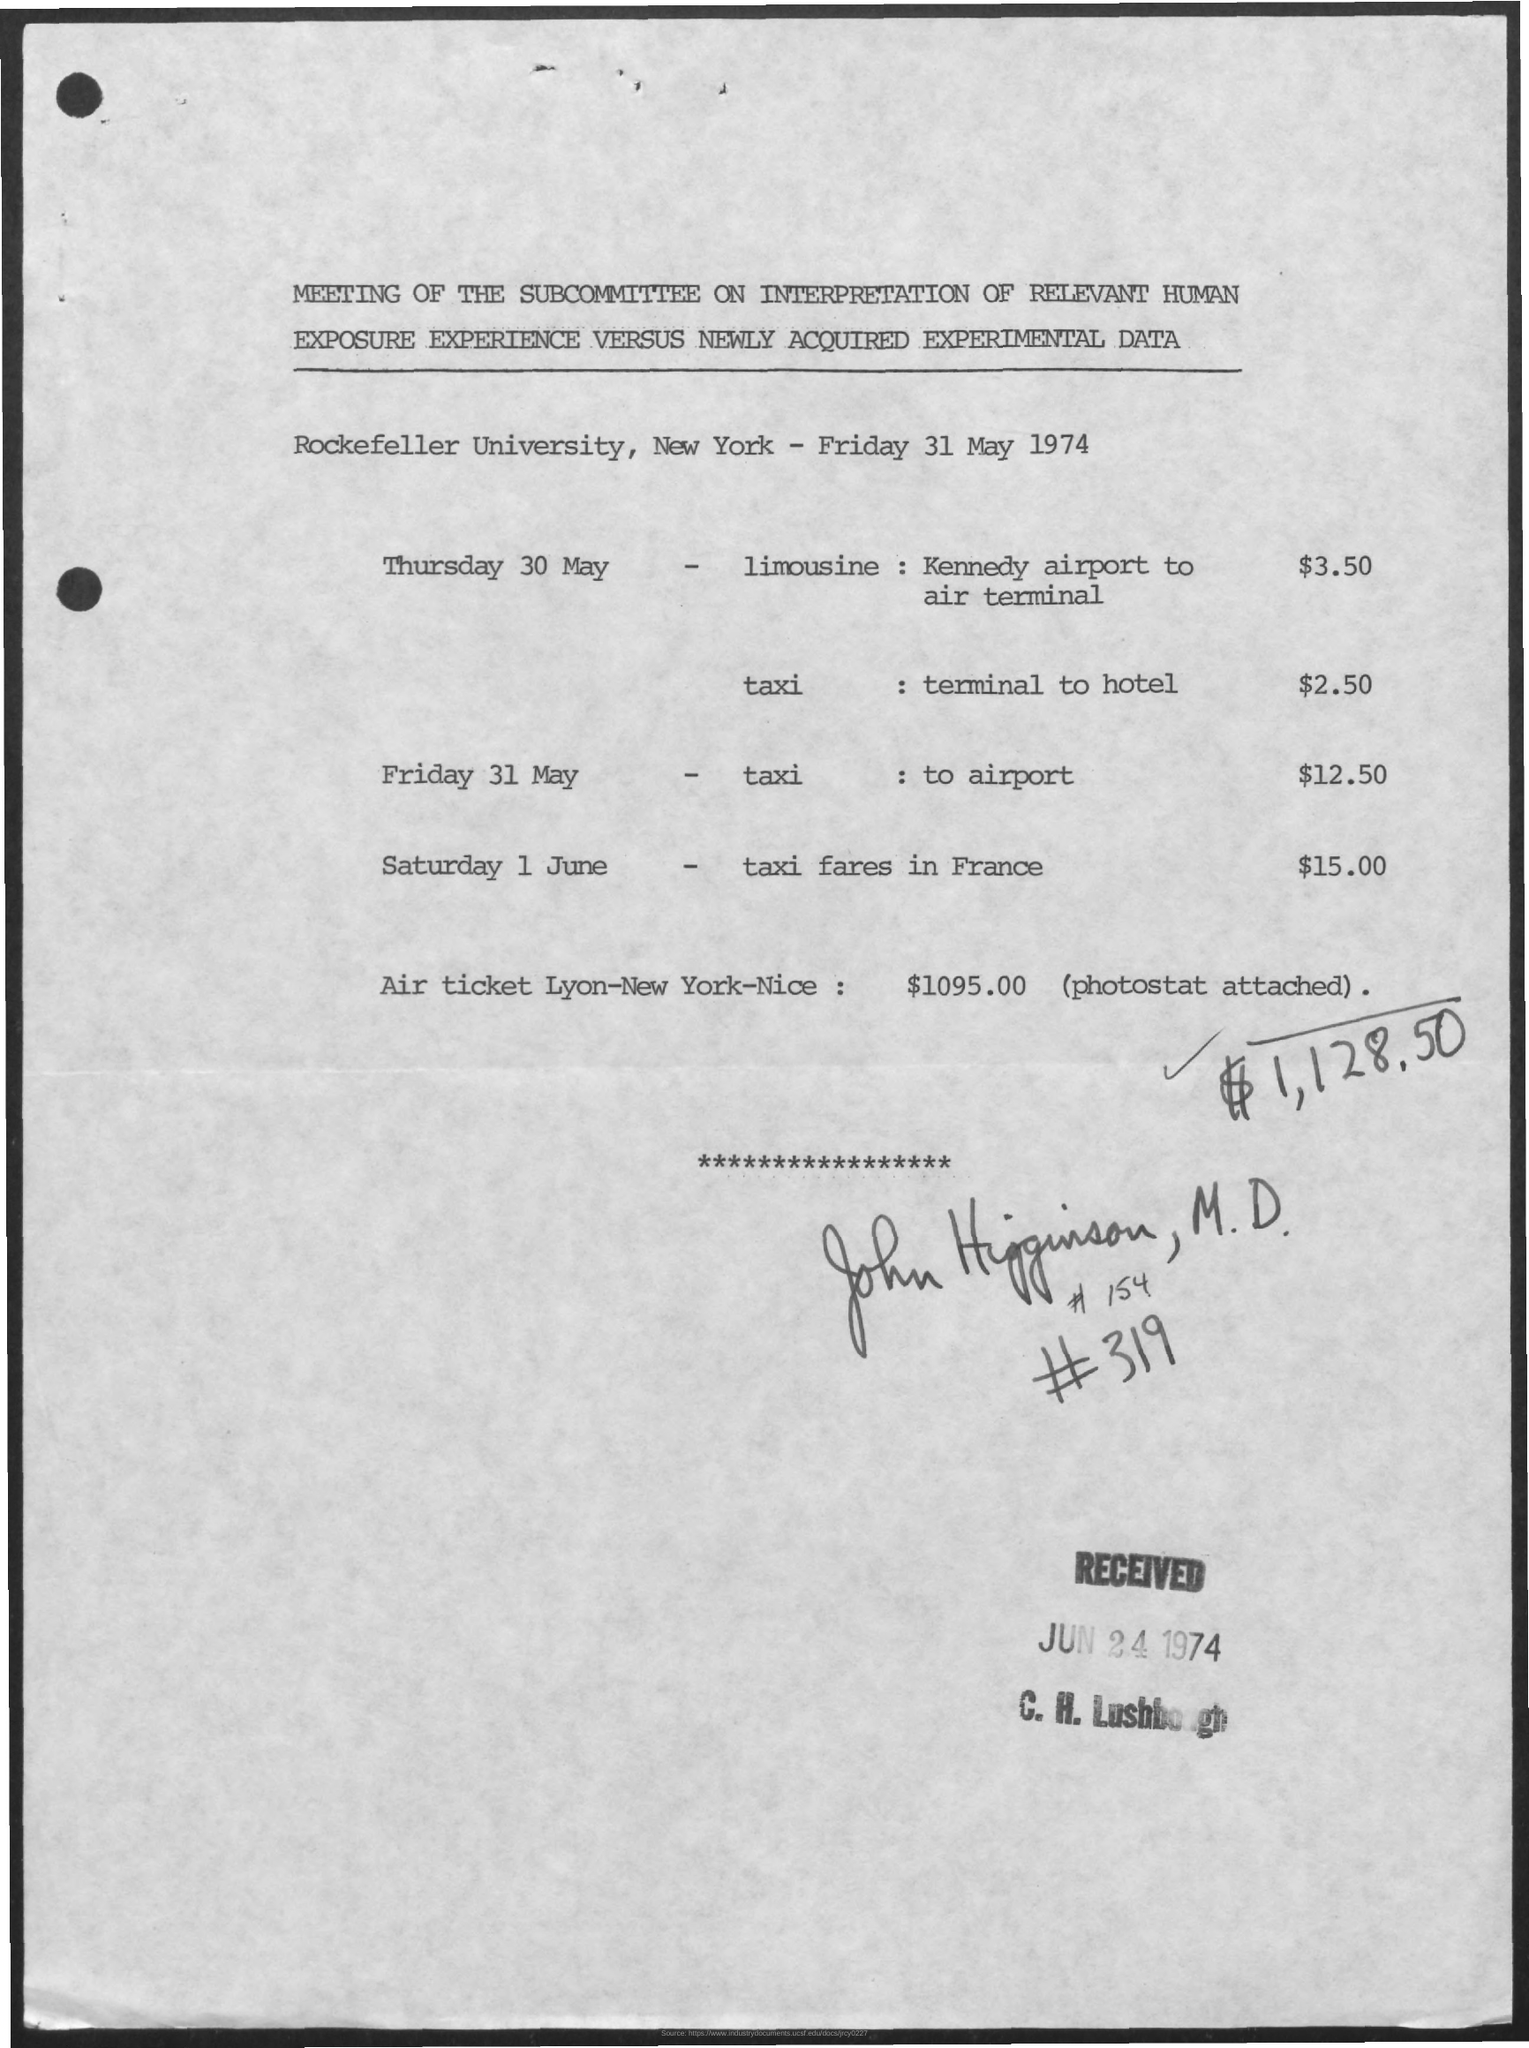Outline some significant characteristics in this image. The taxi fare in France on Saturday, June 1st is $15.00. On Thursday, May 30, the taxi fare from the terminal to the hotel is estimated to be $2.50. The taxi fare to the airport on Friday 31 May is $12.50. On June 24, 1974, the date was received. 